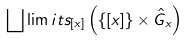<formula> <loc_0><loc_0><loc_500><loc_500>\bigsqcup \lim i t s _ { [ x ] } \left ( \{ [ x ] \} \times \hat { G } _ { x } \right )</formula> 